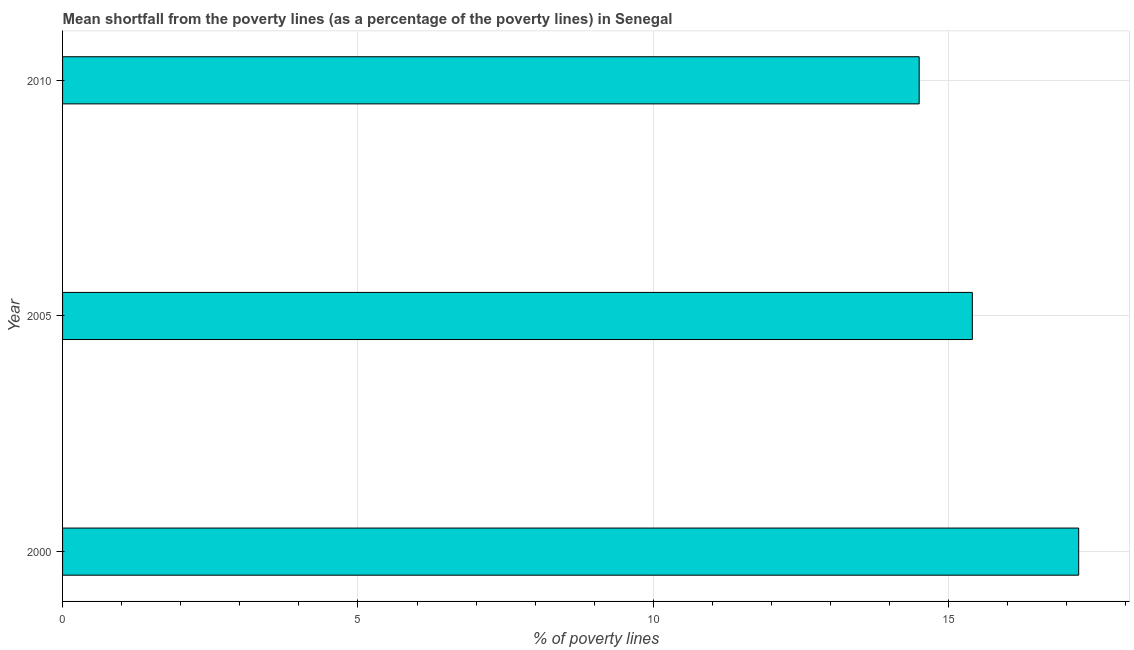What is the title of the graph?
Ensure brevity in your answer.  Mean shortfall from the poverty lines (as a percentage of the poverty lines) in Senegal. What is the label or title of the X-axis?
Your answer should be compact. % of poverty lines. What is the label or title of the Y-axis?
Provide a succinct answer. Year. What is the poverty gap at national poverty lines in 2000?
Ensure brevity in your answer.  17.2. In which year was the poverty gap at national poverty lines maximum?
Your answer should be compact. 2000. What is the sum of the poverty gap at national poverty lines?
Your answer should be very brief. 47.1. In how many years, is the poverty gap at national poverty lines greater than 15 %?
Offer a very short reply. 2. Do a majority of the years between 2000 and 2010 (inclusive) have poverty gap at national poverty lines greater than 4 %?
Offer a very short reply. Yes. What is the ratio of the poverty gap at national poverty lines in 2005 to that in 2010?
Your answer should be compact. 1.06. What is the difference between the highest and the second highest poverty gap at national poverty lines?
Your answer should be very brief. 1.8. How many bars are there?
Ensure brevity in your answer.  3. Are all the bars in the graph horizontal?
Keep it short and to the point. Yes. Are the values on the major ticks of X-axis written in scientific E-notation?
Your response must be concise. No. What is the difference between the % of poverty lines in 2000 and 2005?
Ensure brevity in your answer.  1.8. What is the difference between the % of poverty lines in 2000 and 2010?
Make the answer very short. 2.7. What is the ratio of the % of poverty lines in 2000 to that in 2005?
Provide a short and direct response. 1.12. What is the ratio of the % of poverty lines in 2000 to that in 2010?
Make the answer very short. 1.19. What is the ratio of the % of poverty lines in 2005 to that in 2010?
Give a very brief answer. 1.06. 